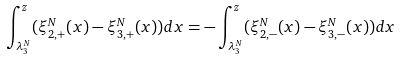<formula> <loc_0><loc_0><loc_500><loc_500>\int _ { \lambda _ { 3 } ^ { N } } ^ { z } ( \xi _ { 2 , + } ^ { N } ( x ) - \xi _ { 3 , + } ^ { N } ( x ) ) d x = - \int _ { \lambda _ { 3 } ^ { N } } ^ { z } ( \xi _ { 2 , - } ^ { N } ( x ) - \xi _ { 3 , - } ^ { N } ( x ) ) d x</formula> 